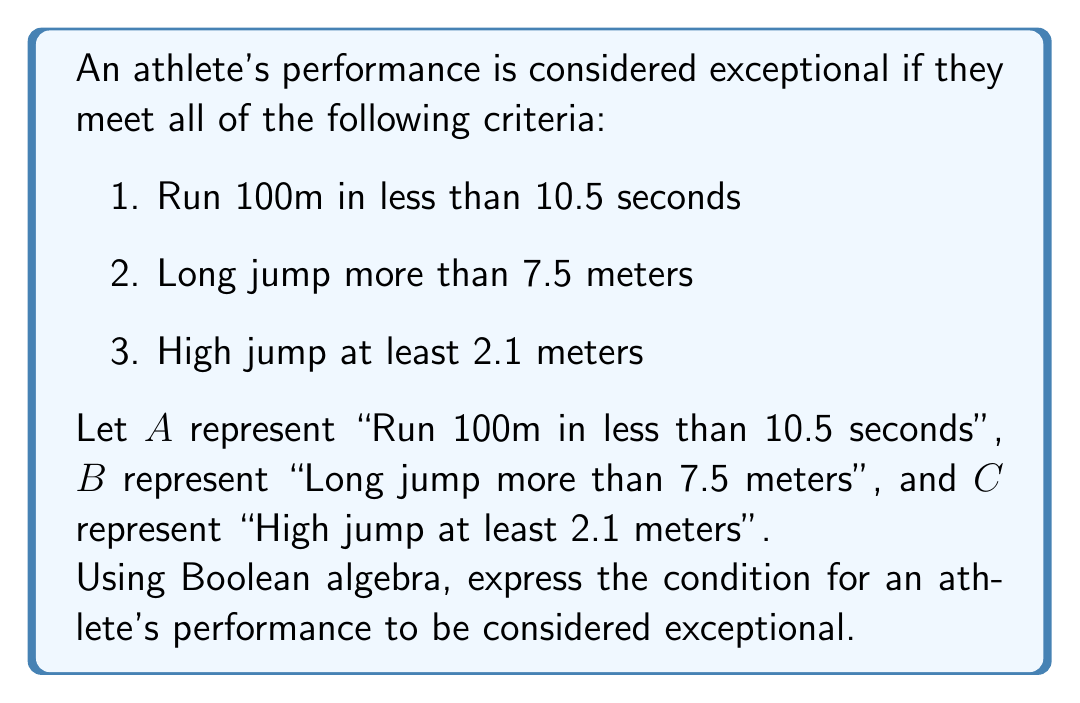Show me your answer to this math problem. To solve this problem, we need to use Boolean algebra to combine the given criteria:

1. First, we identify the variables:
   $A$: Run 100m in less than 10.5 seconds
   $B$: Long jump more than 7.5 meters
   $C$: High jump at least 2.1 meters

2. The athlete's performance is considered exceptional if ALL of these criteria are met. In Boolean algebra, the AND operation is used to represent this condition.

3. The AND operation is typically represented by multiplication or the symbol $\wedge$.

4. Since all three conditions must be true for the performance to be exceptional, we can express this as:

   $A \wedge B \wedge C$

5. This expression means that the athlete's performance is exceptional only if condition $A$ is true AND condition $B$ is true AND condition $C$ is true.

6. In terms of set theory, this would represent the intersection of all three sets of athletes who meet each individual criterion.
Answer: $A \wedge B \wedge C$ 